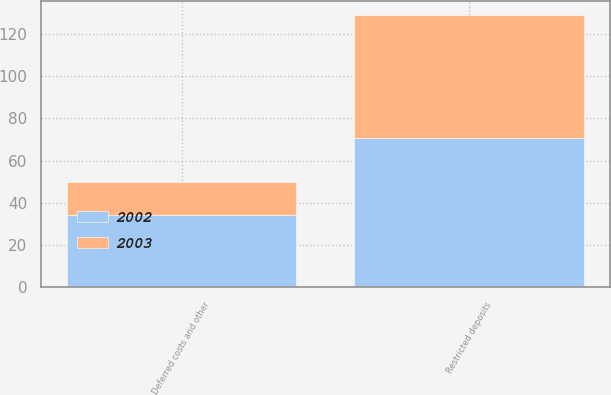Convert chart to OTSL. <chart><loc_0><loc_0><loc_500><loc_500><stacked_bar_chart><ecel><fcel>Restricted deposits<fcel>Deferred costs and other<nl><fcel>2003<fcel>58.2<fcel>15.9<nl><fcel>2002<fcel>70.8<fcel>34.1<nl></chart> 